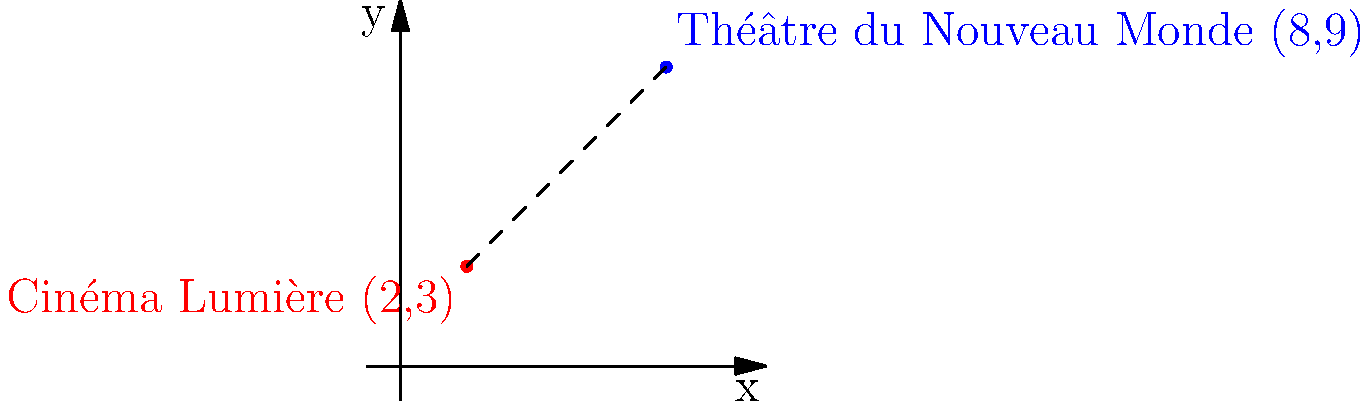Two arthouse cinemas, Cinéma Lumière and Théâtre du Nouveau Monde, are located on a city grid. Cinéma Lumière is at coordinates (2,3), while Théâtre du Nouveau Monde is at (8,9). What is the shortest distance between these two independent film venues, rounded to two decimal places? To find the shortest distance between two points on a coordinate plane, we can use the distance formula, which is derived from the Pythagorean theorem:

$$ d = \sqrt{(x_2 - x_1)^2 + (y_2 - y_1)^2} $$

Where $(x_1, y_1)$ are the coordinates of the first point and $(x_2, y_2)$ are the coordinates of the second point.

Let's plug in our values:
$(x_1, y_1) = (2, 3)$ for Cinéma Lumière
$(x_2, y_2) = (8, 9)$ for Théâtre du Nouveau Monde

$$ d = \sqrt{(8 - 2)^2 + (9 - 3)^2} $$

$$ d = \sqrt{6^2 + 6^2} $$

$$ d = \sqrt{36 + 36} $$

$$ d = \sqrt{72} $$

$$ d \approx 8.4853 $$

Rounding to two decimal places, we get 8.49 units.
Answer: 8.49 units 